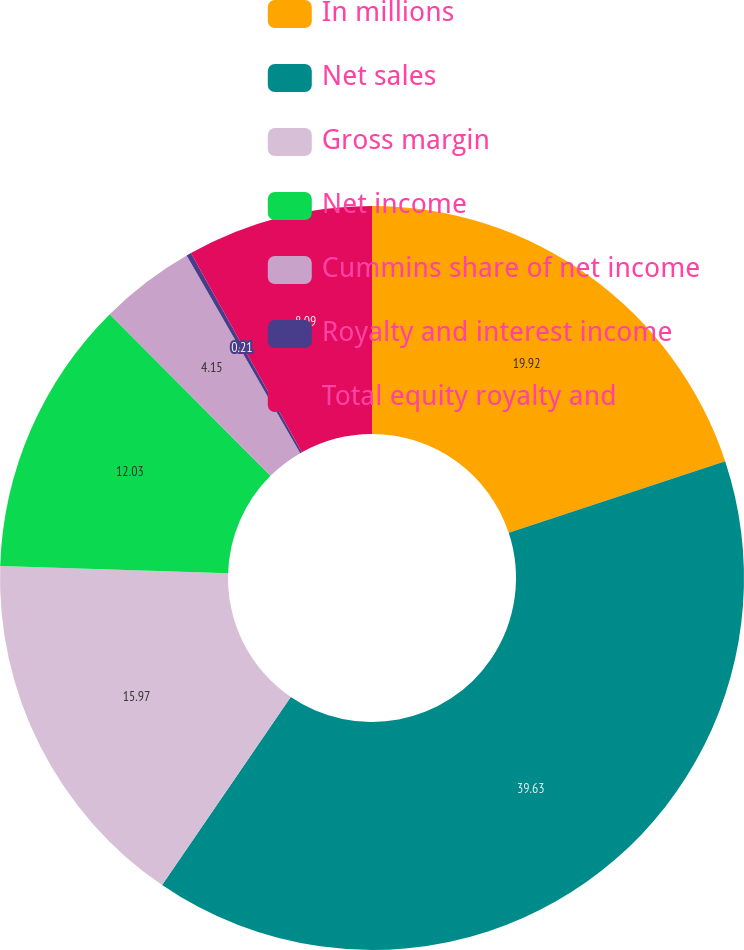<chart> <loc_0><loc_0><loc_500><loc_500><pie_chart><fcel>In millions<fcel>Net sales<fcel>Gross margin<fcel>Net income<fcel>Cummins share of net income<fcel>Royalty and interest income<fcel>Total equity royalty and<nl><fcel>19.91%<fcel>39.62%<fcel>15.97%<fcel>12.03%<fcel>4.15%<fcel>0.21%<fcel>8.09%<nl></chart> 